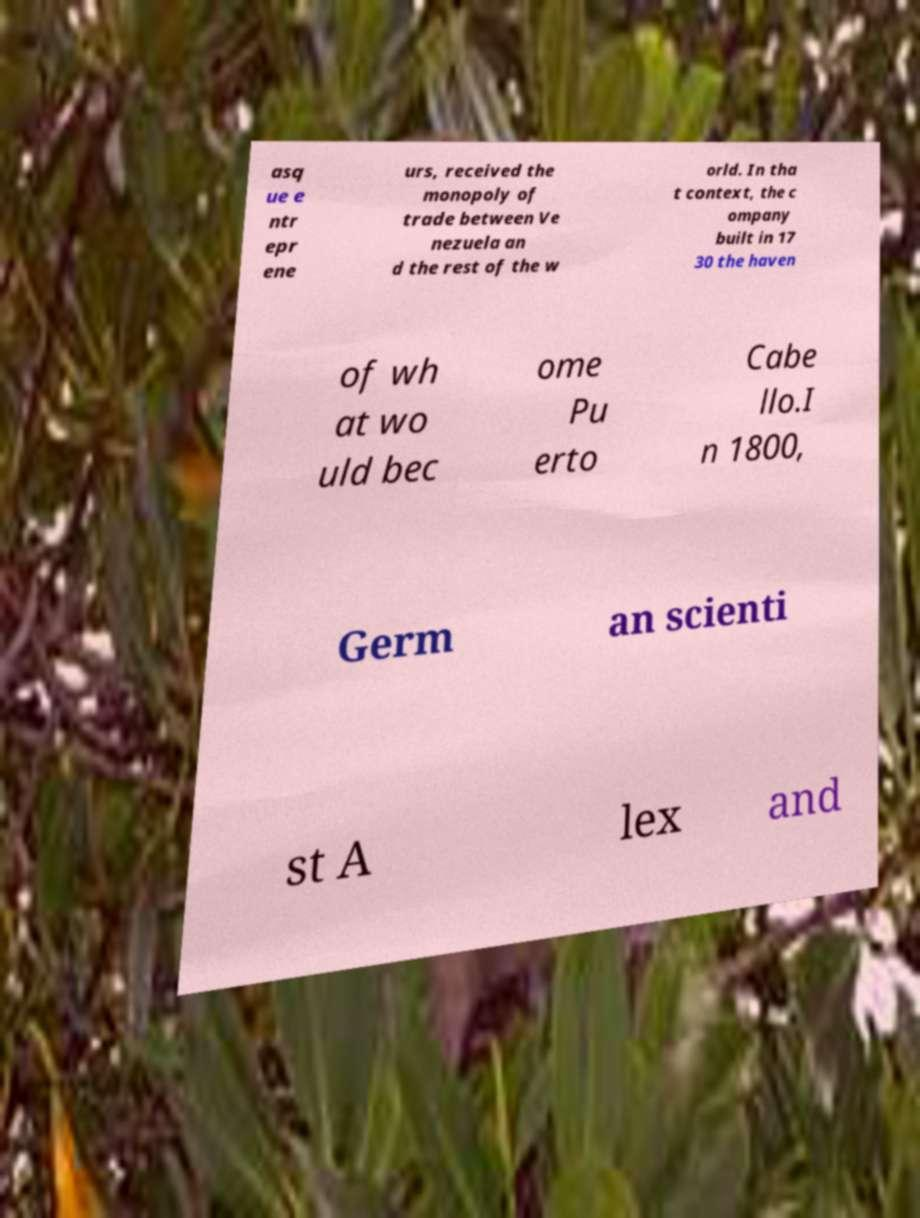Could you assist in decoding the text presented in this image and type it out clearly? asq ue e ntr epr ene urs, received the monopoly of trade between Ve nezuela an d the rest of the w orld. In tha t context, the c ompany built in 17 30 the haven of wh at wo uld bec ome Pu erto Cabe llo.I n 1800, Germ an scienti st A lex and 